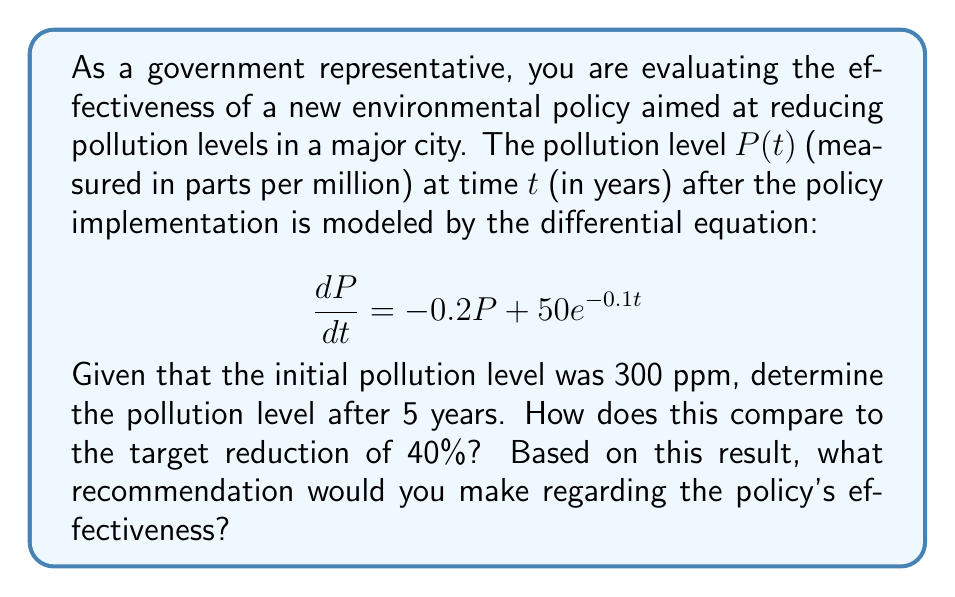Can you solve this math problem? Let's solve this problem step by step:

1) We have the differential equation: $\frac{dP}{dt} = -0.2P + 50e^{-0.1t}$

2) This is a first-order linear differential equation. The general solution is:
   $P(t) = e^{-0.2t}(C + \int 50e^{0.1t}dt)$

3) Solving the integral:
   $P(t) = e^{-0.2t}(C + 500e^{0.1t}) = Ce^{-0.2t} + 500e^{-0.1t}$

4) Given the initial condition $P(0) = 300$, we can find $C$:
   $300 = C + 500$
   $C = -200$

5) Therefore, the particular solution is:
   $P(t) = -200e^{-0.2t} + 500e^{-0.1t}$

6) To find $P(5)$, we substitute $t = 5$:
   $P(5) = -200e^{-1} + 500e^{-0.5}$
   $\approx -73.58 + 303.27 = 229.69$ ppm

7) To calculate the percentage reduction:
   Percentage reduction = $\frac{300 - 229.69}{300} \times 100\% \approx 23.44\%$

8) The target reduction was 40%, but the actual reduction is only about 23.44%.
Answer: The pollution level after 5 years is approximately 229.69 ppm, a 23.44% reduction. As this falls short of the 40% target, the policy appears only partially effective and may need enhancement or additional measures to meet the desired goal. 